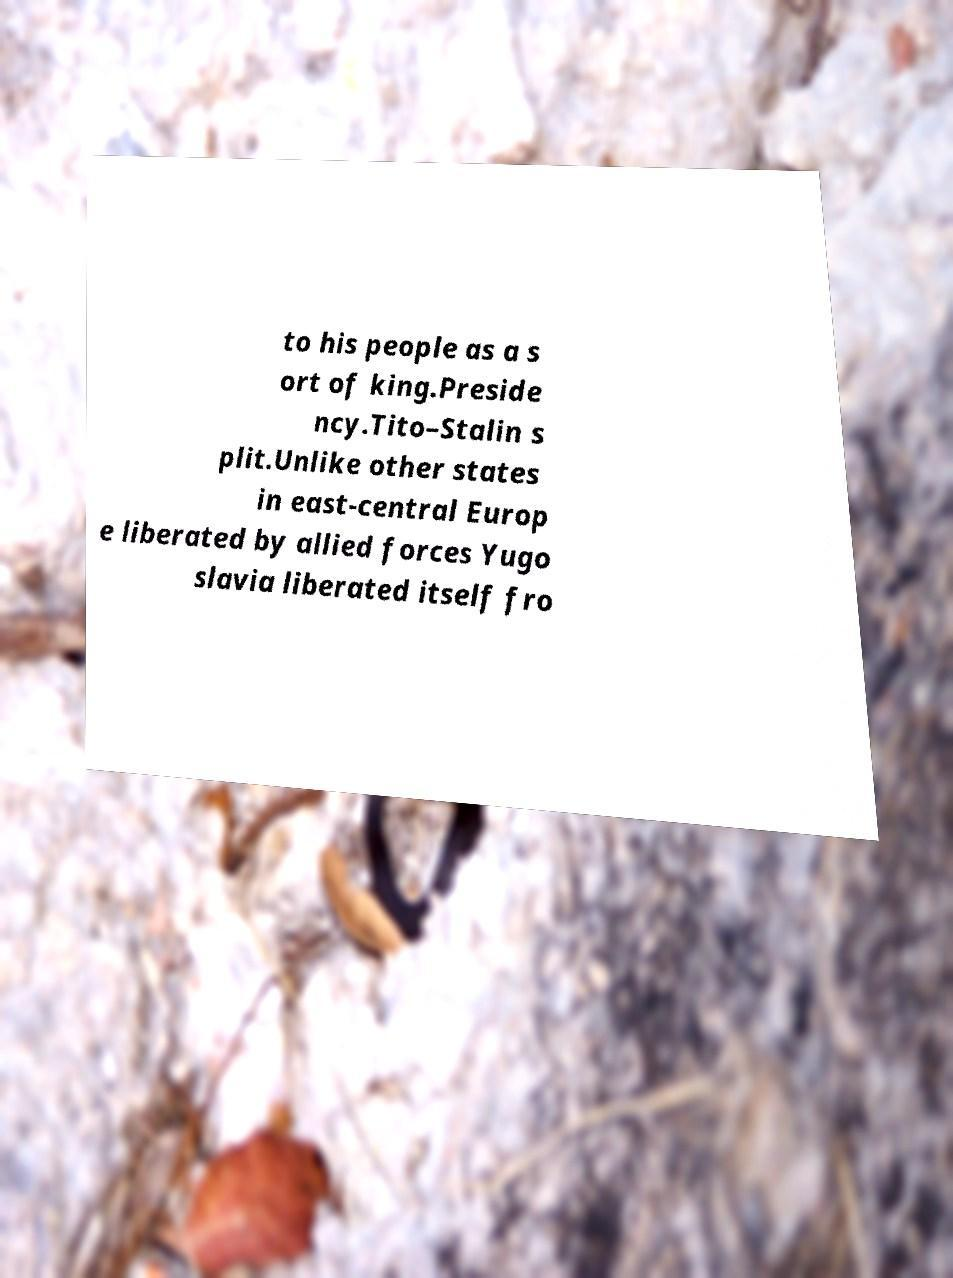Please identify and transcribe the text found in this image. to his people as a s ort of king.Preside ncy.Tito–Stalin s plit.Unlike other states in east-central Europ e liberated by allied forces Yugo slavia liberated itself fro 